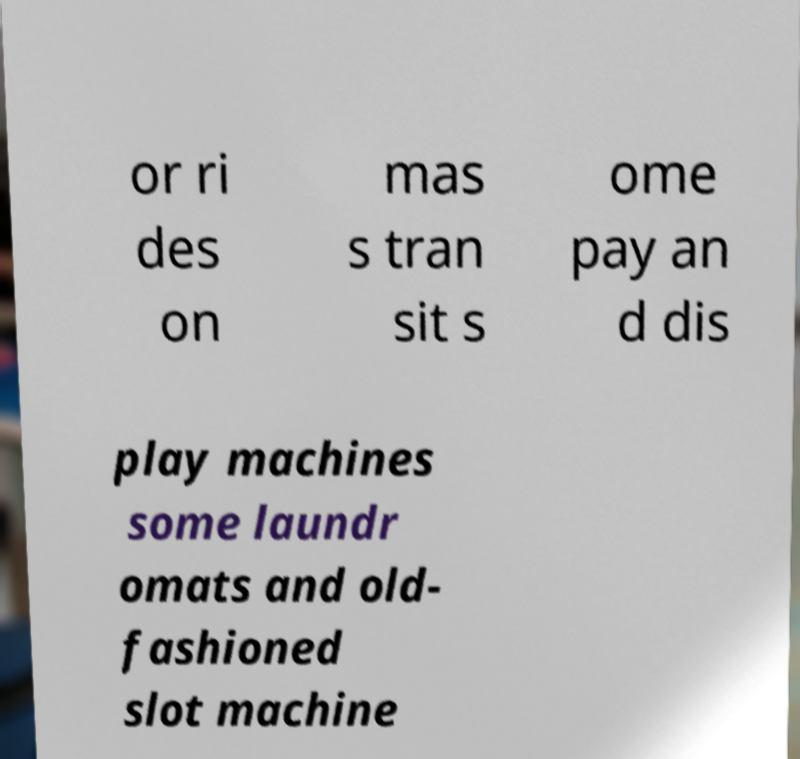For documentation purposes, I need the text within this image transcribed. Could you provide that? or ri des on mas s tran sit s ome pay an d dis play machines some laundr omats and old- fashioned slot machine 